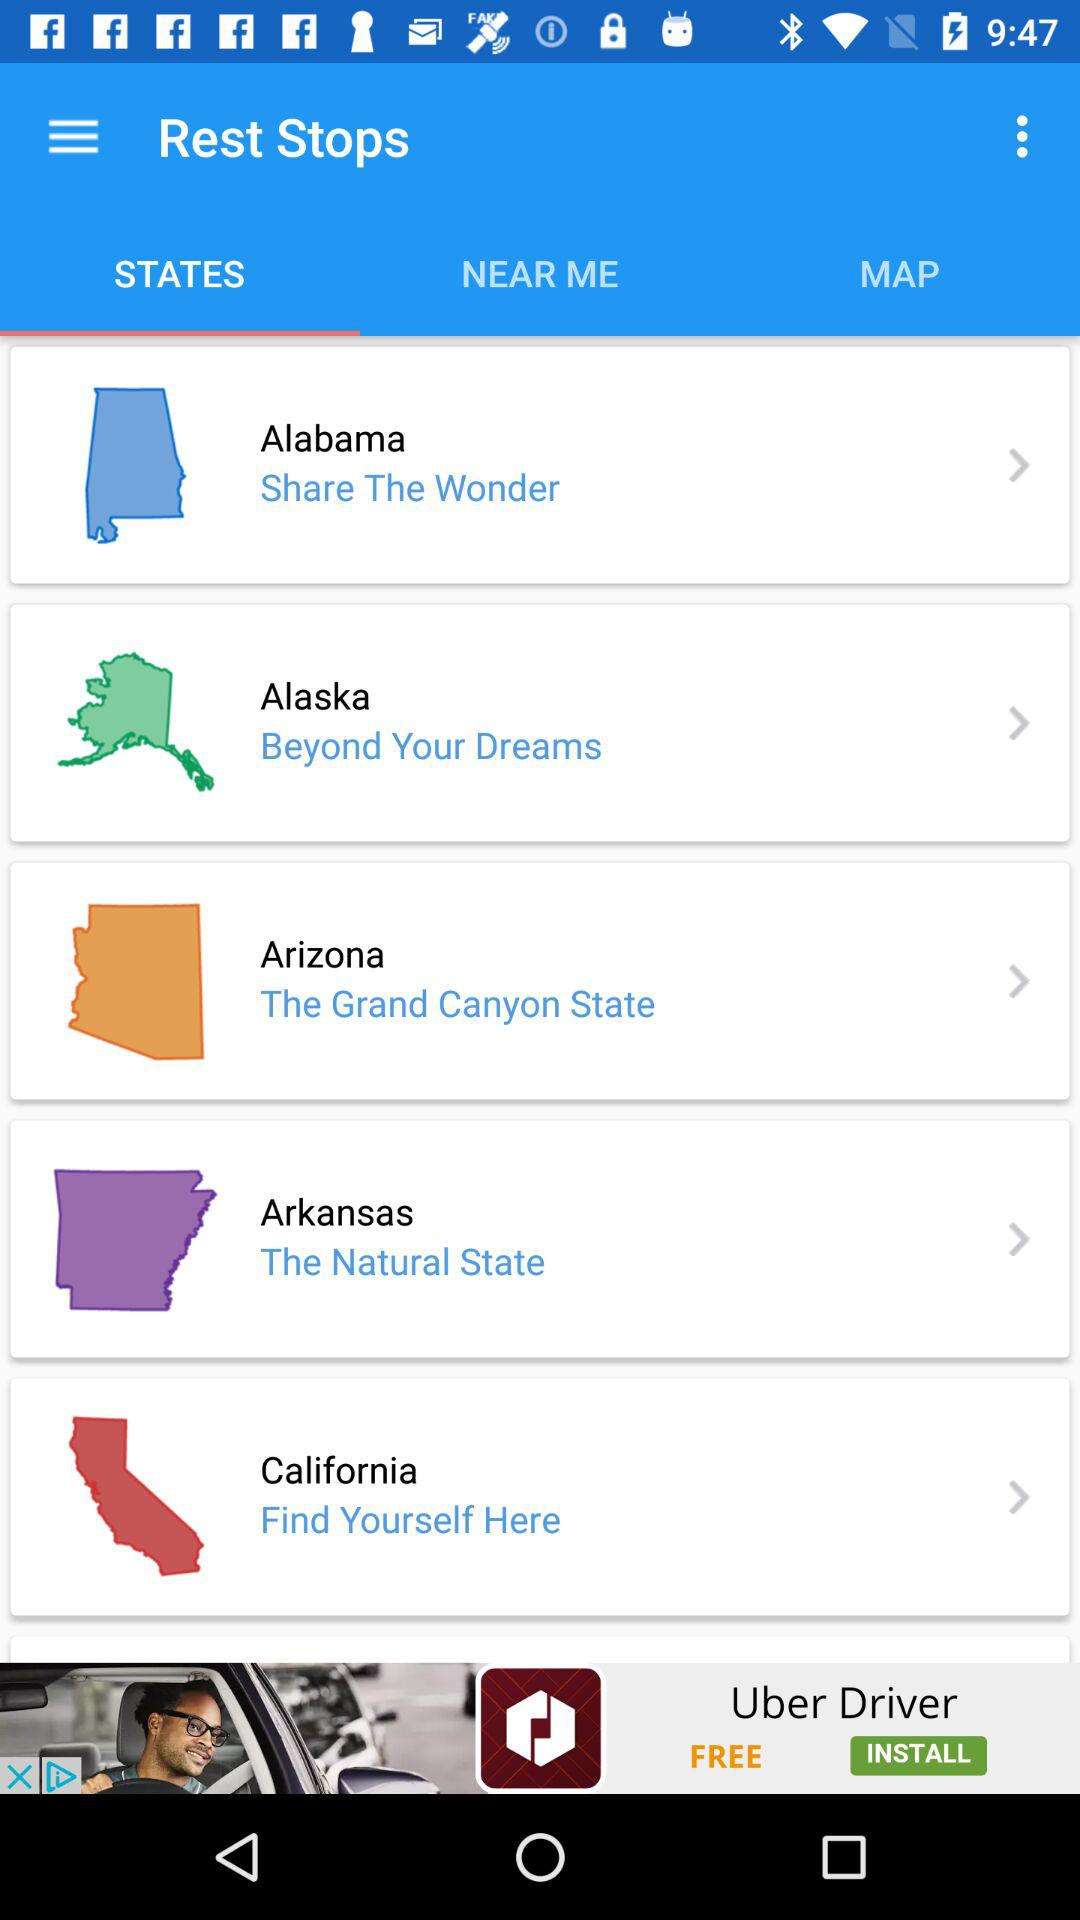Which tab is selected? The selected tab is "STATES". 